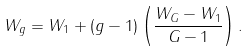<formula> <loc_0><loc_0><loc_500><loc_500>W _ { g } = W _ { 1 } + ( g - 1 ) \left ( \frac { W _ { G } - W _ { 1 } } { G - 1 } \right ) .</formula> 